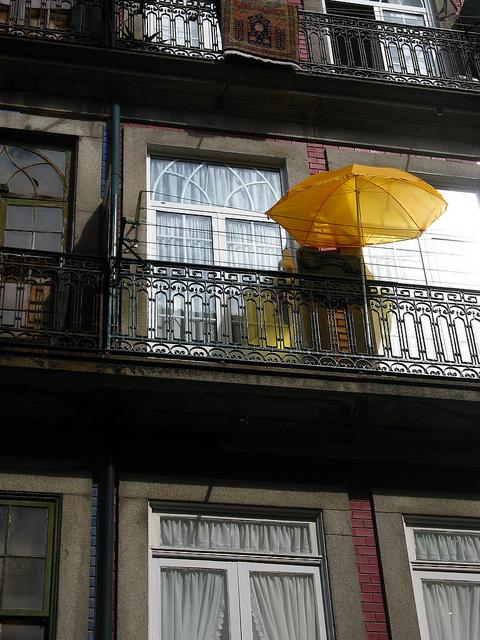Is there a window open?
Be succinct. Yes. How many stories up is the umbrella?
Answer briefly. 2. Are the railings plain or ornate?
Short answer required. Ornate. 